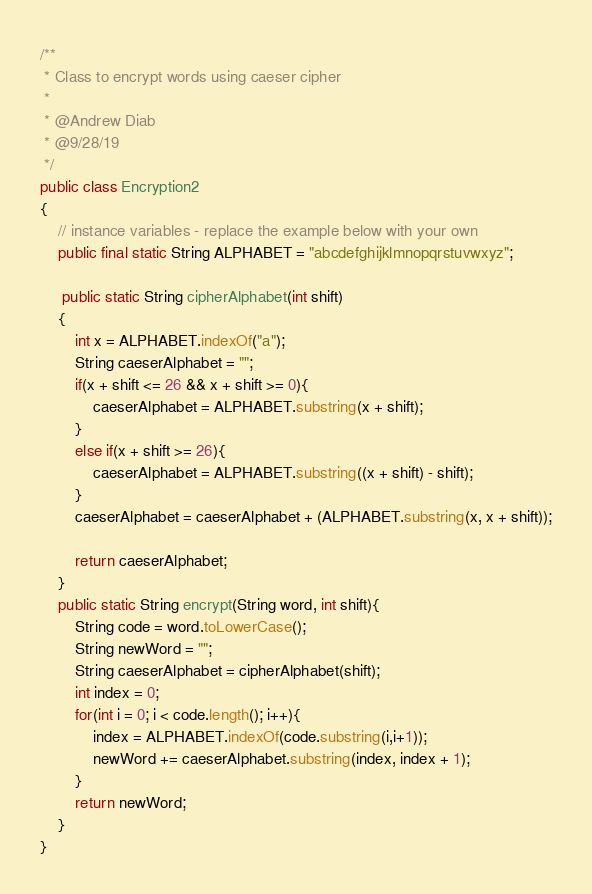<code> <loc_0><loc_0><loc_500><loc_500><_Java_>
/**
 * Class to encrypt words using caeser cipher
 *
 * @Andrew Diab
 * @9/28/19
 */
public class Encryption2
{
    // instance variables - replace the example below with your own
    public final static String ALPHABET = "abcdefghijklmnopqrstuvwxyz";

     public static String cipherAlphabet(int shift)
    {
        int x = ALPHABET.indexOf("a");
        String caeserAlphabet = "";
        if(x + shift <= 26 && x + shift >= 0){
            caeserAlphabet = ALPHABET.substring(x + shift);
        }
        else if(x + shift >= 26){
            caeserAlphabet = ALPHABET.substring((x + shift) - shift); 
        }
        caeserAlphabet = caeserAlphabet + (ALPHABET.substring(x, x + shift));
        
        return caeserAlphabet;
    }
    public static String encrypt(String word, int shift){
        String code = word.toLowerCase();
        String newWord = "";
        String caeserAlphabet = cipherAlphabet(shift);
        int index = 0;
        for(int i = 0; i < code.length(); i++){
            index = ALPHABET.indexOf(code.substring(i,i+1));
            newWord += caeserAlphabet.substring(index, index + 1);
        }
        return newWord;
    }
}

</code> 